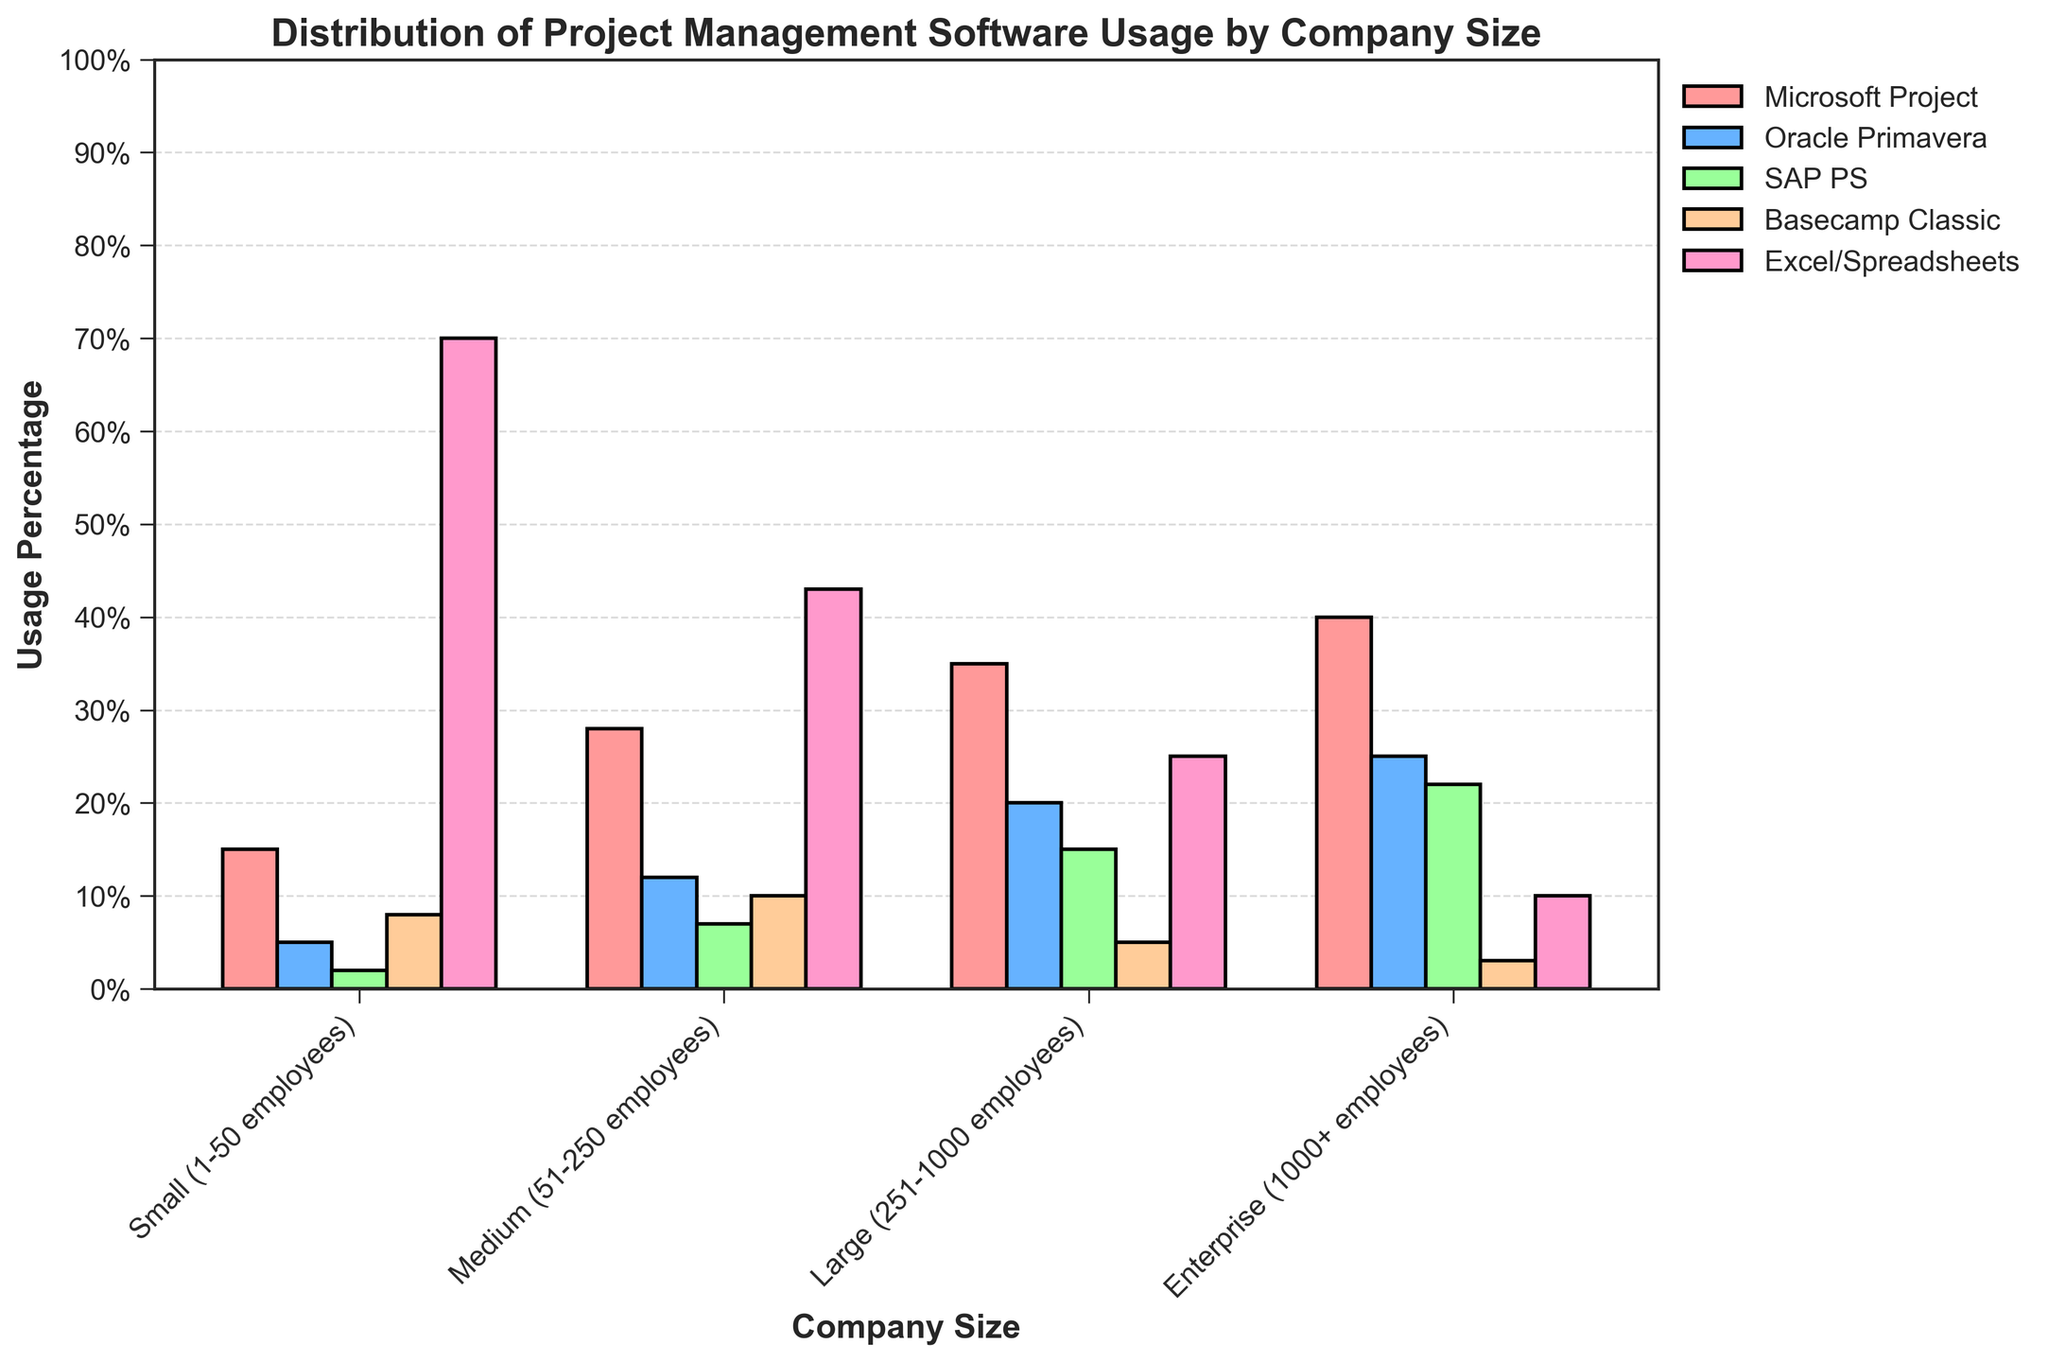What's the most commonly used project management tool for small companies? From the figure, observe the bar heights for small companies. The tallest bar corresponds to Excel/Spreadsheets at 70%.
Answer: Excel/Spreadsheets Which tool is exclusively more used by enterprise companies than small companies? Compare the bars for enterprise and small companies for each tool. Microsoft Project, Oracle Primavera, and SAP PS have higher percentages for enterprise companies. However, the one with the largest exclusive increase is Oracle Primavera increasing from 5% to 25%.
Answer: Oracle Primavera How does the usage of Excel/Spreadsheets compare between small and enterprise companies? Look at the heights of the bars representing Excel/Spreadsheets for small and enterprise companies. Excel/Spreadsheets are used by 70% of small companies but only 10% of enterprise companies. The percentage decreases significantly.
Answer: Decreases significantly Which company size relies most heavily on Microsoft Project? Identify the largest bar for Microsoft Project across all company sizes. The tallest bar corresponds to enterprise companies at 40%.
Answer: Enterprise Considering the usage of traditional tools (Microsoft Project, Oracle Primavera, SAP PS, Excel/Spreadsheets), what’s the combined usage percentage in medium companies? Add the percentages for Microsoft Project (28%), Oracle Primavera (12%), SAP PS (7%), and Excel/Spreadsheets (43%) in medium companies. 28% + 12% + 7% + 43% = 90%.
Answer: 90% How much more prevalent is SAP PS in large companies compared to small companies? Compare the heights of the bars for SAP PS between large and small companies. SAP PS in large companies is 15%, and in small companies, it is 2%. The difference is 15% - 2% = 13%.
Answer: 13% What is the least popular project management tool for large companies? Identify the shortest bar for large companies. The shortest bar corresponds to Basecamp Classic at 5%.
Answer: Basecamp Classic What’s the average usage of Oracle Primavera across all company sizes? Sum the percentages of Oracle Primavera usage across all company sizes (5% + 12% + 20% + 25%) and divide by the number of groups (4). The calculation is (5 + 12 + 20 + 25) / 4 = 15.5%.
Answer: 15.5% What is the most striking difference in software usage between small and large companies? Compare the bars for all software tools between small and large companies. Excel/Spreadsheets show a striking difference where small companies use it 70% and large companies use it 25%, a difference of 45%.
Answer: Excel/Spreadsheets Which company size shows the most balanced usage distribution across all tools? Look at the relative heights of the bars for each company size. Medium companies have the most balanced distribution compared to small, large, and enterprise where one tool dominates usage.
Answer: Medium 